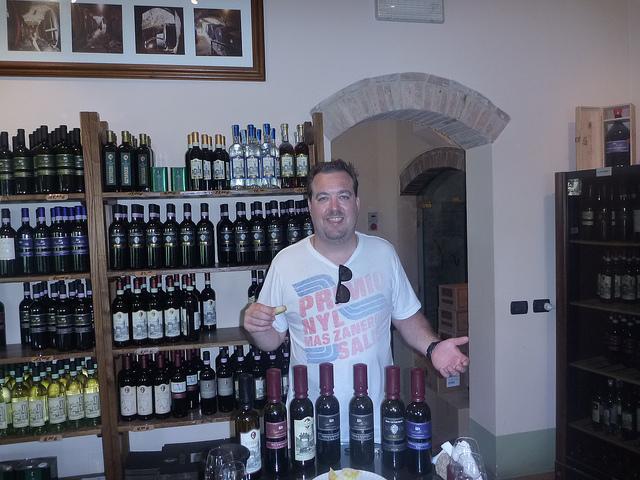How many wines are merlo?
Short answer required. 3. What is he buying?
Keep it brief. Wine. Is this at a grocery store?
Keep it brief. No. How many bottles are in front of the man?
Answer briefly. 7. 